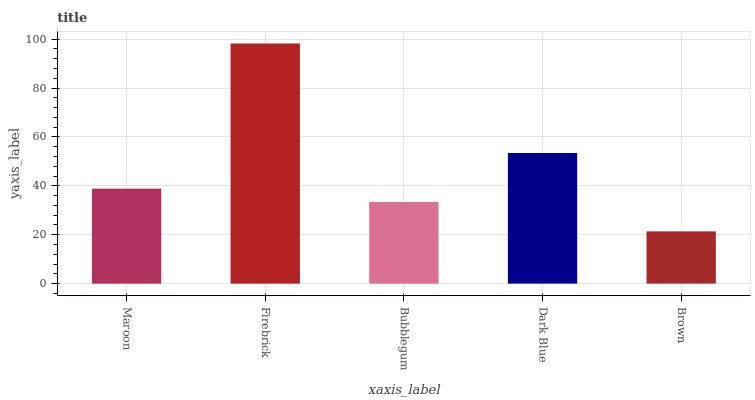Is Brown the minimum?
Answer yes or no. Yes. Is Firebrick the maximum?
Answer yes or no. Yes. Is Bubblegum the minimum?
Answer yes or no. No. Is Bubblegum the maximum?
Answer yes or no. No. Is Firebrick greater than Bubblegum?
Answer yes or no. Yes. Is Bubblegum less than Firebrick?
Answer yes or no. Yes. Is Bubblegum greater than Firebrick?
Answer yes or no. No. Is Firebrick less than Bubblegum?
Answer yes or no. No. Is Maroon the high median?
Answer yes or no. Yes. Is Maroon the low median?
Answer yes or no. Yes. Is Bubblegum the high median?
Answer yes or no. No. Is Firebrick the low median?
Answer yes or no. No. 